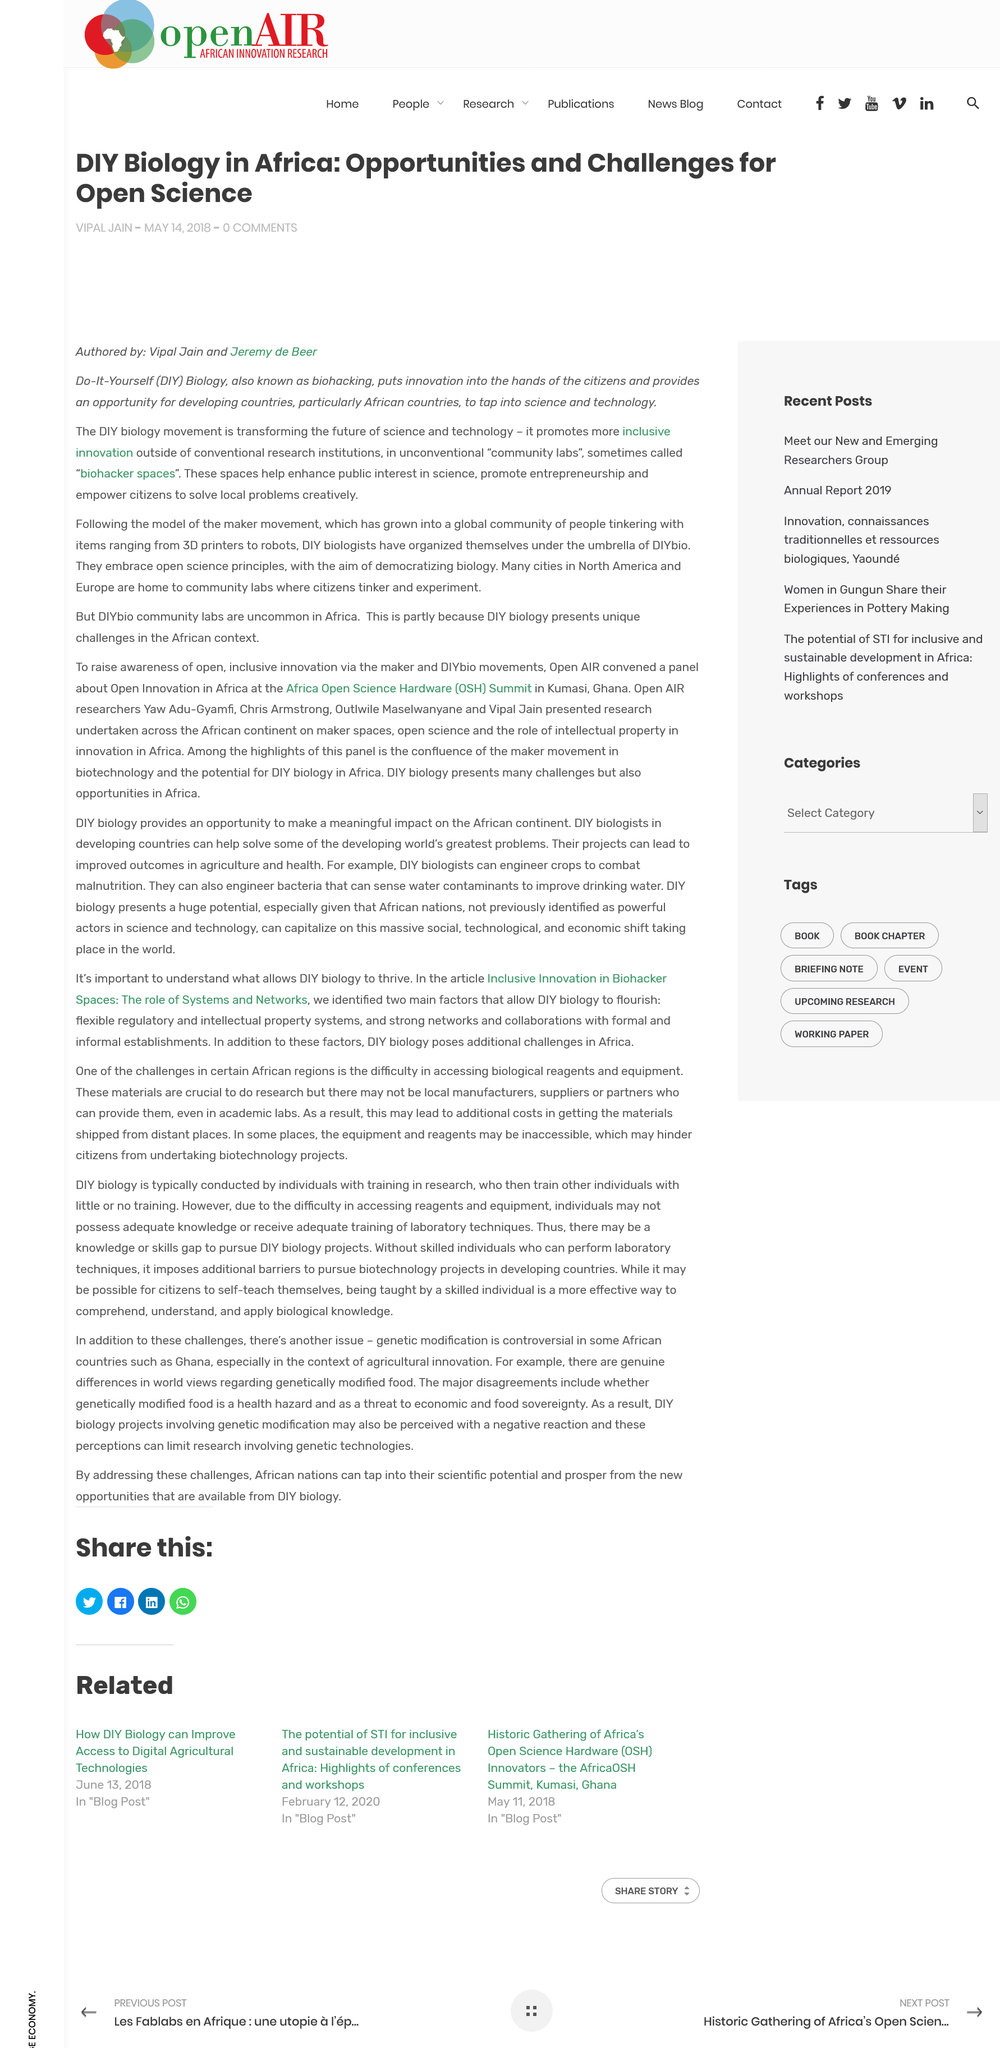Specify some key components in this picture. Unconventional community labs that aim to enhance public interest in science, promote entrepreneurship, and empower citizens to solve local problems creatively, are sometimes referred to as biohacker spaces. Vipal Jain and Jeremy de Beer are the authors of the book "DIY Biology in Africa: Opportunities and Challenges for Open Science. Do-It-Yourself Biology, commonly referred to as Biohacking, is the practice of conducting biological experiments and manipulating genetic material without the supervision of professionals in the field. 